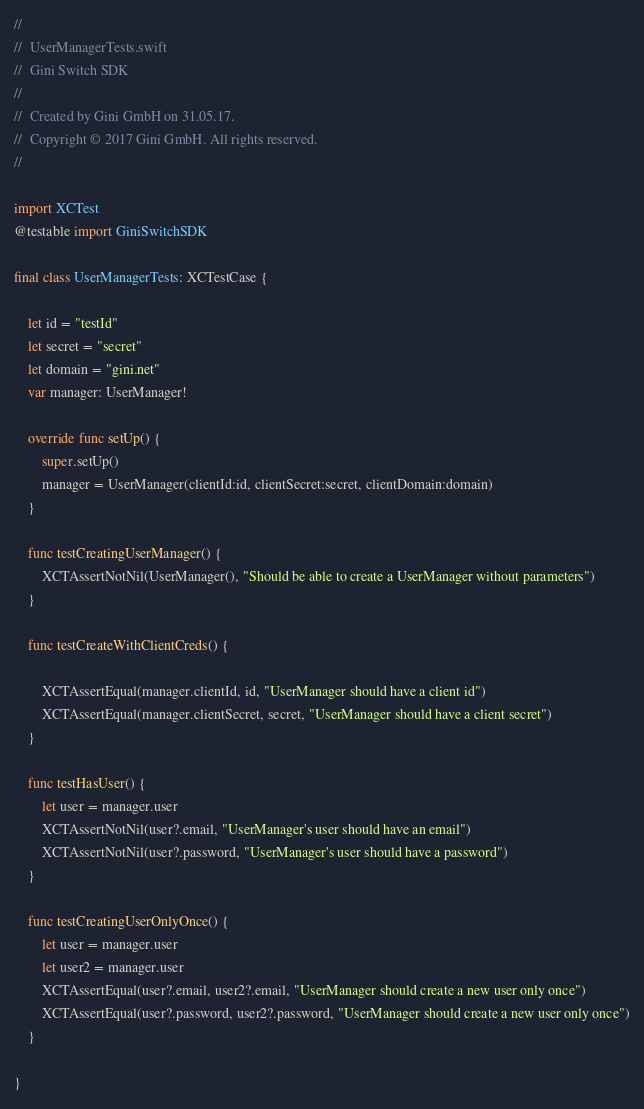<code> <loc_0><loc_0><loc_500><loc_500><_Swift_>//
//  UserManagerTests.swift
//  Gini Switch SDK
//
//  Created by Gini GmbH on 31.05.17.
//  Copyright © 2017 Gini GmbH. All rights reserved.
//

import XCTest
@testable import GiniSwitchSDK

final class UserManagerTests: XCTestCase {
    
    let id = "testId"
    let secret = "secret"
    let domain = "gini.net"
    var manager: UserManager!
    
    override func setUp() {
        super.setUp()
        manager = UserManager(clientId:id, clientSecret:secret, clientDomain:domain)
    }
    
    func testCreatingUserManager() {
        XCTAssertNotNil(UserManager(), "Should be able to create a UserManager without parameters")
    }
    
    func testCreateWithClientCreds() {
        
        XCTAssertEqual(manager.clientId, id, "UserManager should have a client id")
        XCTAssertEqual(manager.clientSecret, secret, "UserManager should have a client secret")
    }
    
    func testHasUser() {
        let user = manager.user
        XCTAssertNotNil(user?.email, "UserManager's user should have an email")
        XCTAssertNotNil(user?.password, "UserManager's user should have a password")
    }
    
    func testCreatingUserOnlyOnce() {
        let user = manager.user
        let user2 = manager.user
        XCTAssertEqual(user?.email, user2?.email, "UserManager should create a new user only once")
        XCTAssertEqual(user?.password, user2?.password, "UserManager should create a new user only once")
    }
    
}
</code> 